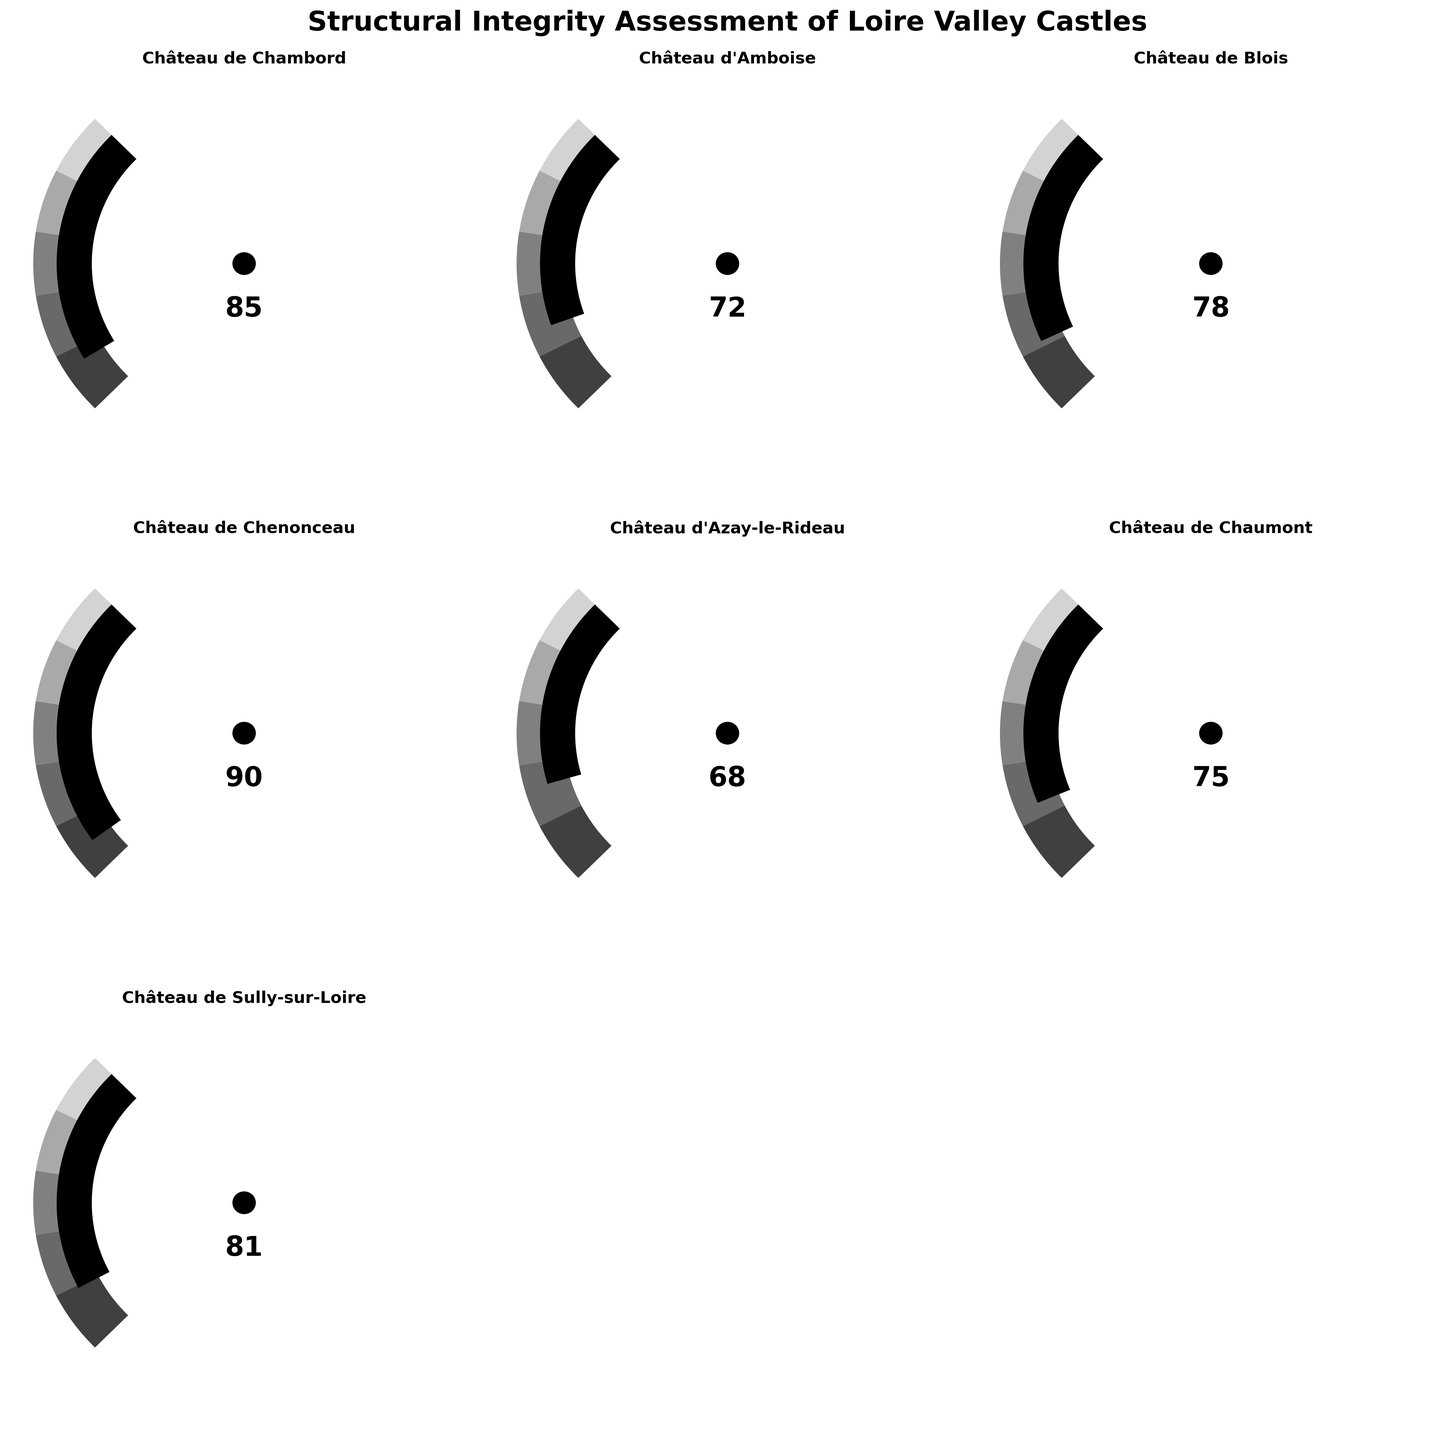1. What is the title of the figure? The title of the figure is mentioned at the top of the plot.
Answer: Structural Integrity Assessment of Loire Valley Castles 2. Which castle has the highest structural integrity score? From the gauges, the castle with the largest score shown is Château de Chenonceau with a score of 90.
Answer: Château de Chenonceau 3. What is the score of Château de Blois? The gauge chart for Château de Blois shows a score of 78.
Answer: 78 4. How many castles have a structural integrity score above 80? Looking at the gauges, only Château de Chambord (85), Château de Chenonceau (90), and Château de Sully-sur-Loire (81) have scores above 80.
Answer: 3 5. What is the average score of the castles shown in the gauges? To find the average, sum all the scores and divide by the number of castles: (85 + 72 + 78 + 90 + 68 + 75 + 81) / 7 = 549 / 7 ≈ 78.43.
Answer: ≈ 78.43 6. Which castle has a lower structural integrity score: Château d'Amboise or Château d'Azay-le-Rideau? The gauge chart shows Château d'Amboise with 72 and Château d'Azay-le-Rideau with 68. Château d'Azay-le-Rideau has a lower score.
Answer: Château d'Azay-le-Rideau 7. What is the median structural integrity score of the castles? To find the median, first list the scores in ascending order: 68, 72, 75, 78, 81, 85, 90. The middle value is the fourth one from this list, which is 78.
Answer: 78 8. How many castles scored below 70? From the gauges, only Château d'Azay-le-Rideau with 68 has below 70.
Answer: 1 9. What is the range of the structural integrity scores in the figure? The maximum score is 90 (Château de Chenonceau) and the minimum is 68 (Château d'Azay-le-Rideau), so the range is 90 - 68 = 22.
Answer: 22 10. How much greater is the score of Château de Chenonceau compared to Château d'Azay-le-Rideau? The score difference can be calculated as 90 - 68 = 22.
Answer: 22 